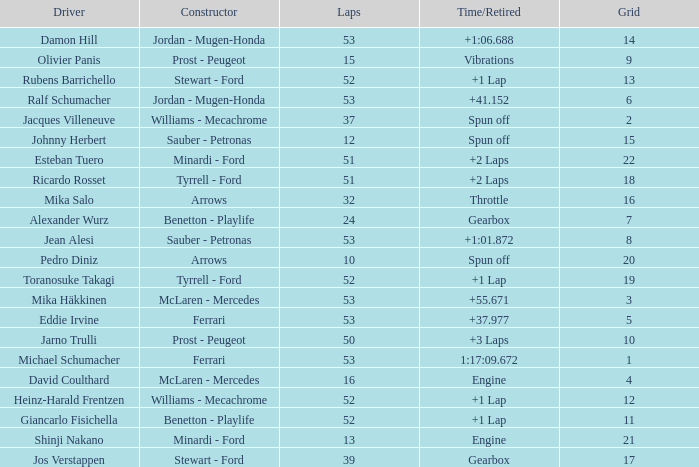Who built the car that went 53 laps with a Time/Retired of 1:17:09.672? Ferrari. 